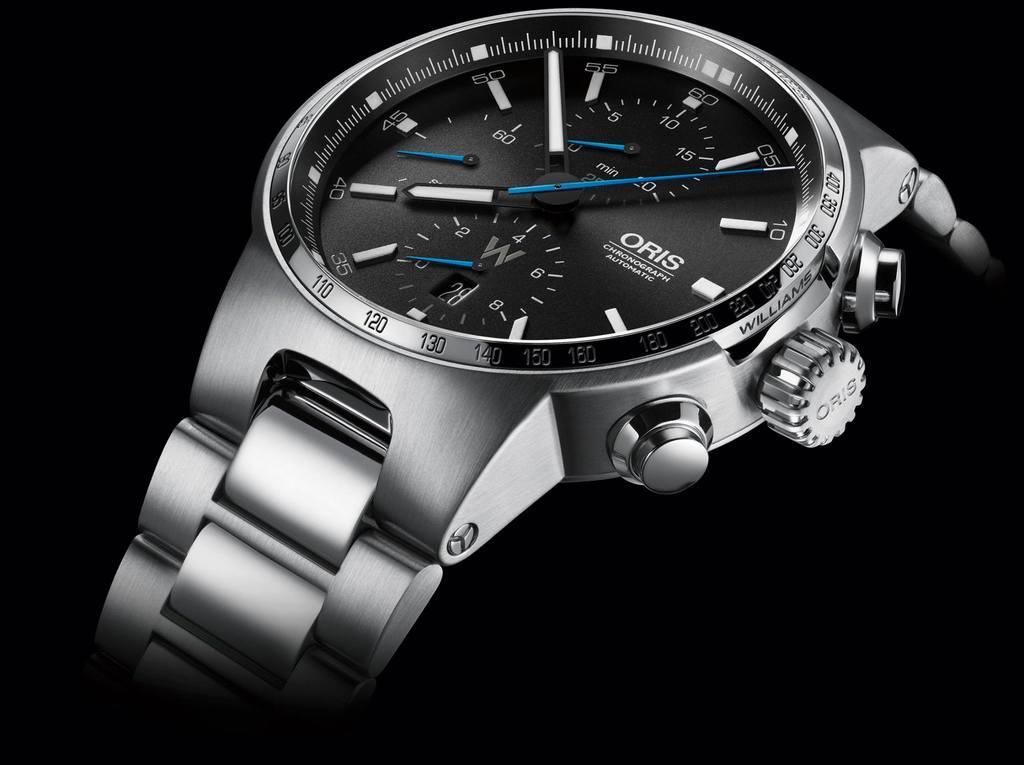How would you summarize this image in a sentence or two? In this image I can see the watch which is in silver color. And I can see the dial is in black color. And there is a black background. 